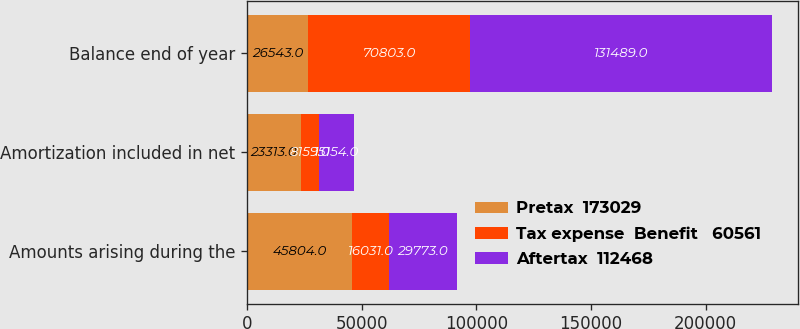Convert chart. <chart><loc_0><loc_0><loc_500><loc_500><stacked_bar_chart><ecel><fcel>Amounts arising during the<fcel>Amortization included in net<fcel>Balance end of year<nl><fcel>Pretax  173029<fcel>45804<fcel>23313<fcel>26543<nl><fcel>Tax expense  Benefit   60561<fcel>16031<fcel>8159<fcel>70803<nl><fcel>Aftertax  112468<fcel>29773<fcel>15154<fcel>131489<nl></chart> 